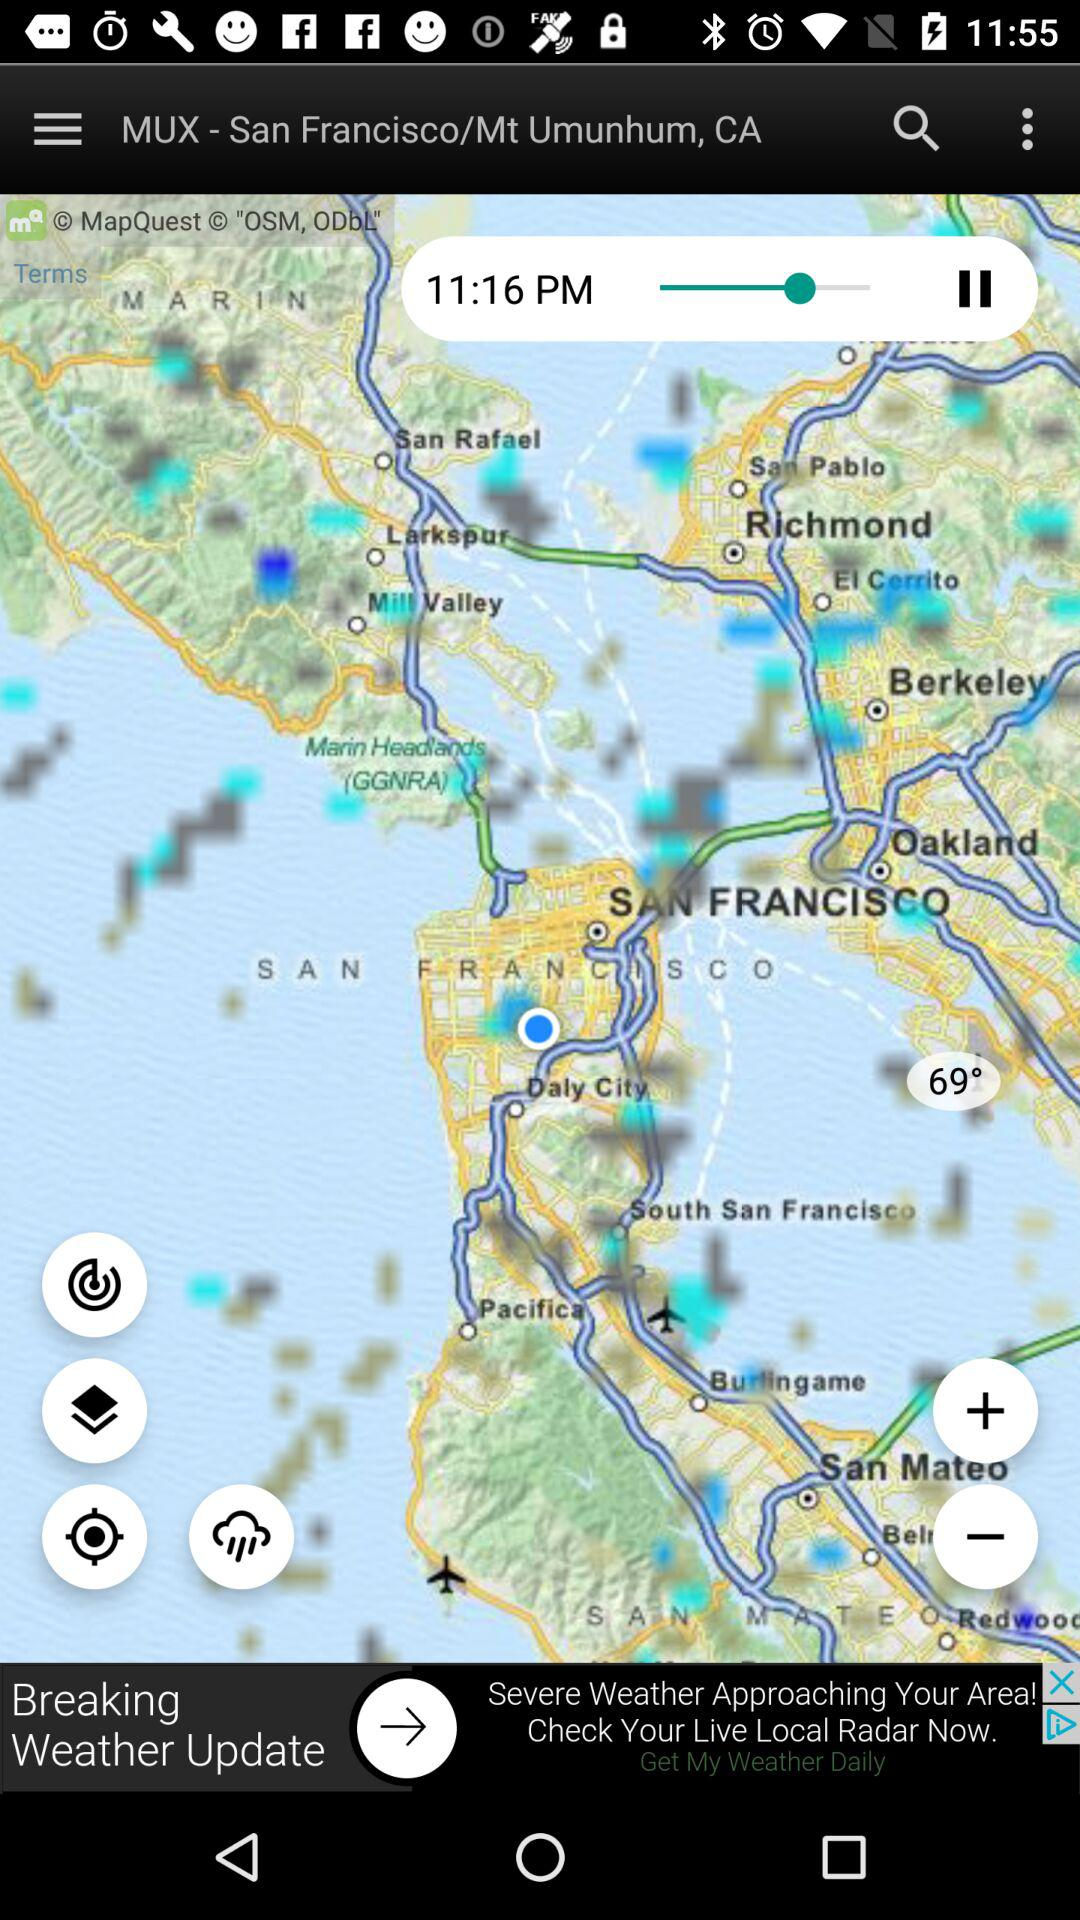What time is shown on the screen? The time shown on the screen is 11:16 p.m. 